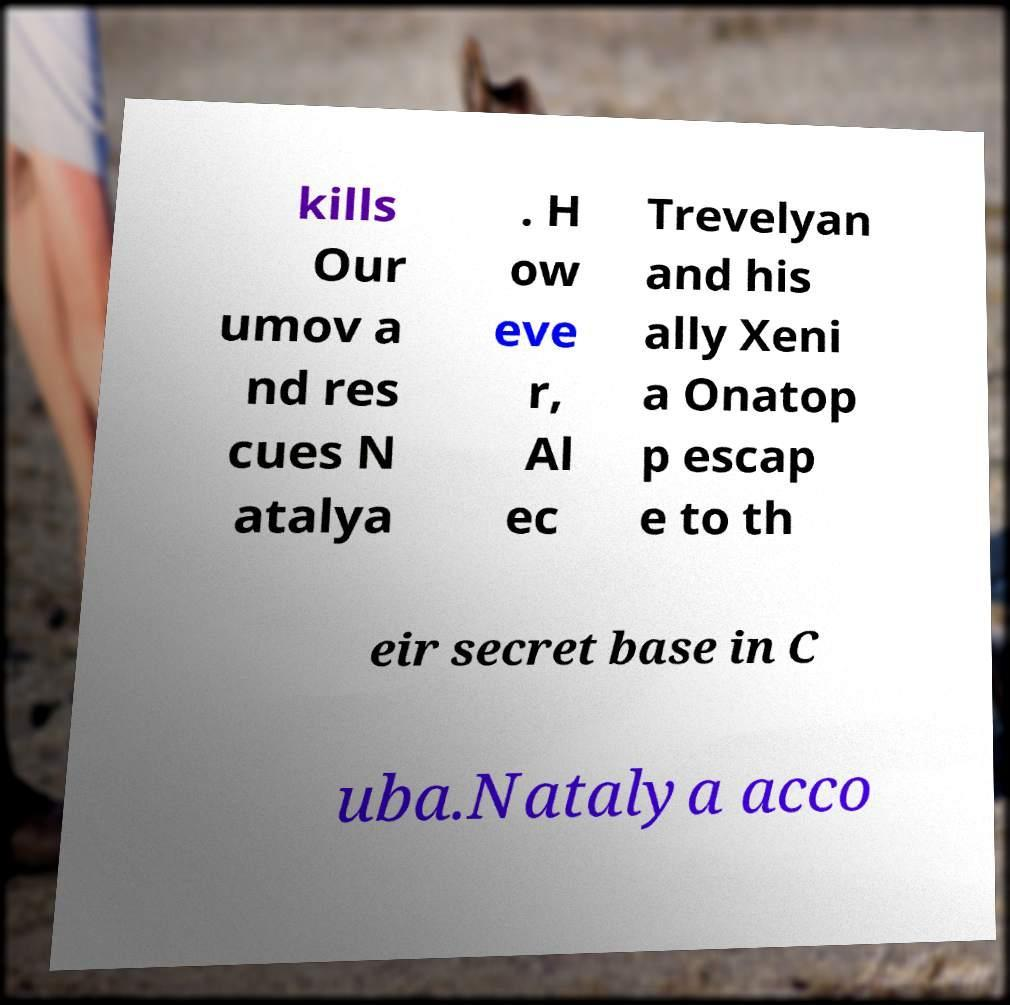Could you assist in decoding the text presented in this image and type it out clearly? kills Our umov a nd res cues N atalya . H ow eve r, Al ec Trevelyan and his ally Xeni a Onatop p escap e to th eir secret base in C uba.Natalya acco 